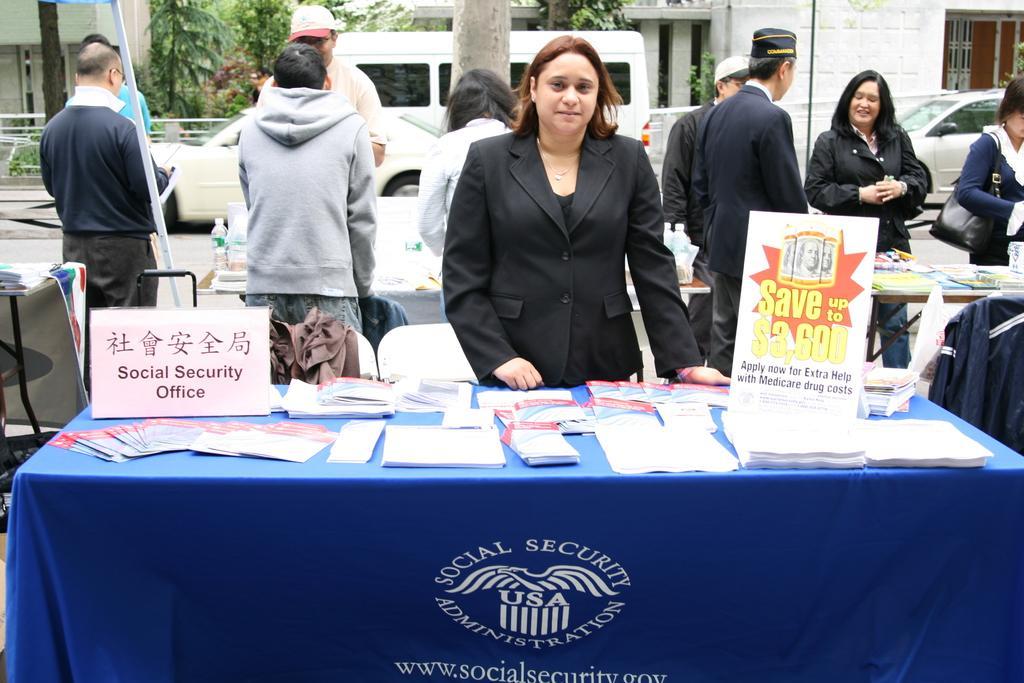In one or two sentences, can you explain what this image depicts? In the center of the image there is a woman standing. There is a table covered with blue color cloth in front of the woman and on the table there are cards, papers, books and text boards. Behind the women there are few people standing near the tables. Image also consists of bottles, jacket and a pole. In the background there are trees, buildings and vehicles on the road. 